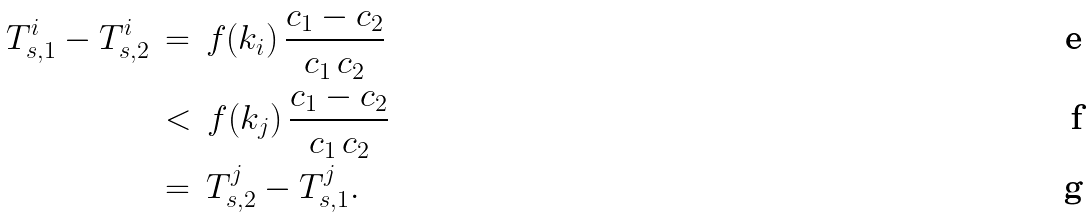<formula> <loc_0><loc_0><loc_500><loc_500>T _ { s , 1 } ^ { i } - T _ { s , 2 } ^ { i } \, & = \, f ( k _ { i } ) \, \frac { c _ { 1 } - c _ { 2 } } { c _ { 1 } \, c _ { 2 } } \\ & < \, f ( k _ { j } ) \, \frac { c _ { 1 } - c _ { 2 } } { c _ { 1 } \, c _ { 2 } } \\ & = \, T _ { s , 2 } ^ { j } - T _ { s , 1 } ^ { j } .</formula> 